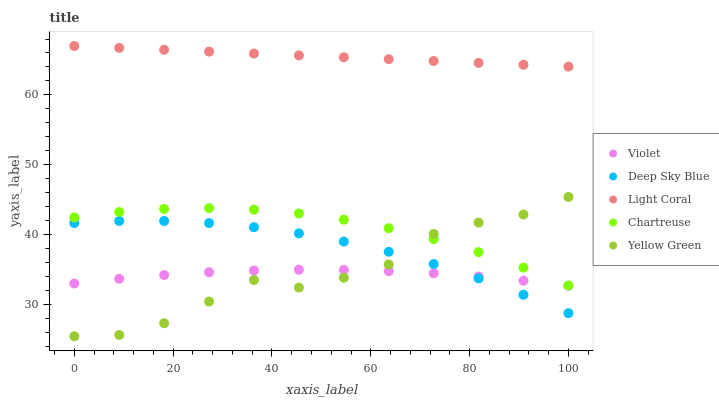Does Violet have the minimum area under the curve?
Answer yes or no. Yes. Does Light Coral have the maximum area under the curve?
Answer yes or no. Yes. Does Chartreuse have the minimum area under the curve?
Answer yes or no. No. Does Chartreuse have the maximum area under the curve?
Answer yes or no. No. Is Light Coral the smoothest?
Answer yes or no. Yes. Is Yellow Green the roughest?
Answer yes or no. Yes. Is Chartreuse the smoothest?
Answer yes or no. No. Is Chartreuse the roughest?
Answer yes or no. No. Does Yellow Green have the lowest value?
Answer yes or no. Yes. Does Chartreuse have the lowest value?
Answer yes or no. No. Does Light Coral have the highest value?
Answer yes or no. Yes. Does Chartreuse have the highest value?
Answer yes or no. No. Is Yellow Green less than Light Coral?
Answer yes or no. Yes. Is Light Coral greater than Yellow Green?
Answer yes or no. Yes. Does Yellow Green intersect Chartreuse?
Answer yes or no. Yes. Is Yellow Green less than Chartreuse?
Answer yes or no. No. Is Yellow Green greater than Chartreuse?
Answer yes or no. No. Does Yellow Green intersect Light Coral?
Answer yes or no. No. 